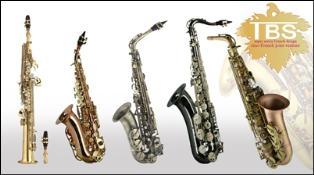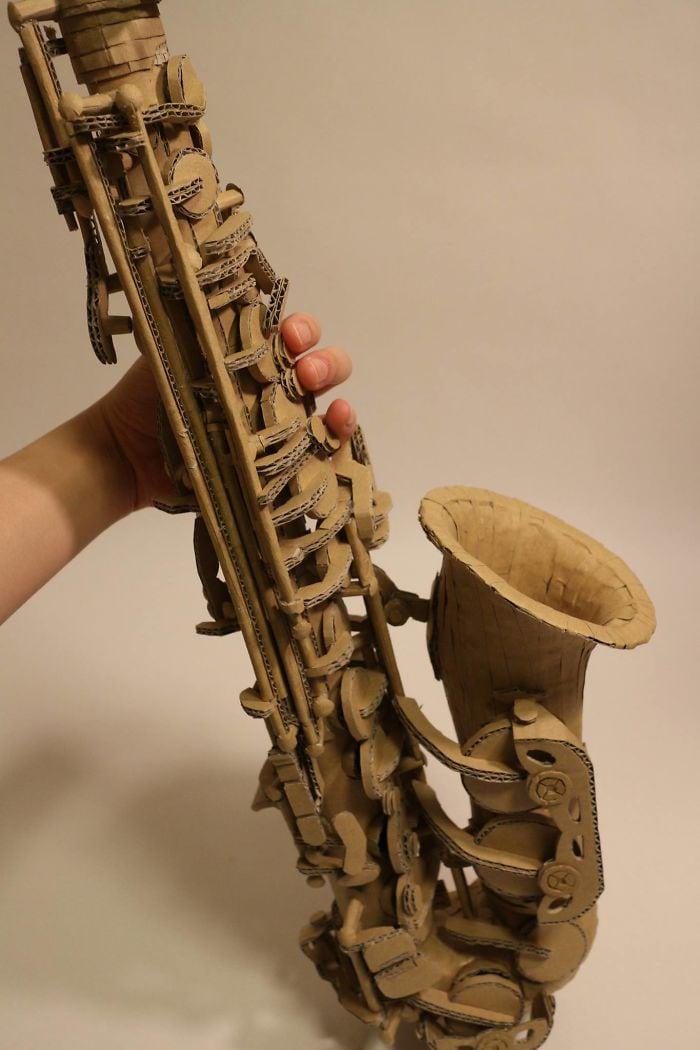The first image is the image on the left, the second image is the image on the right. Assess this claim about the two images: "An image shows a row of at least four instruments, and the one on the far left does not have an upturned bell.". Correct or not? Answer yes or no. Yes. 